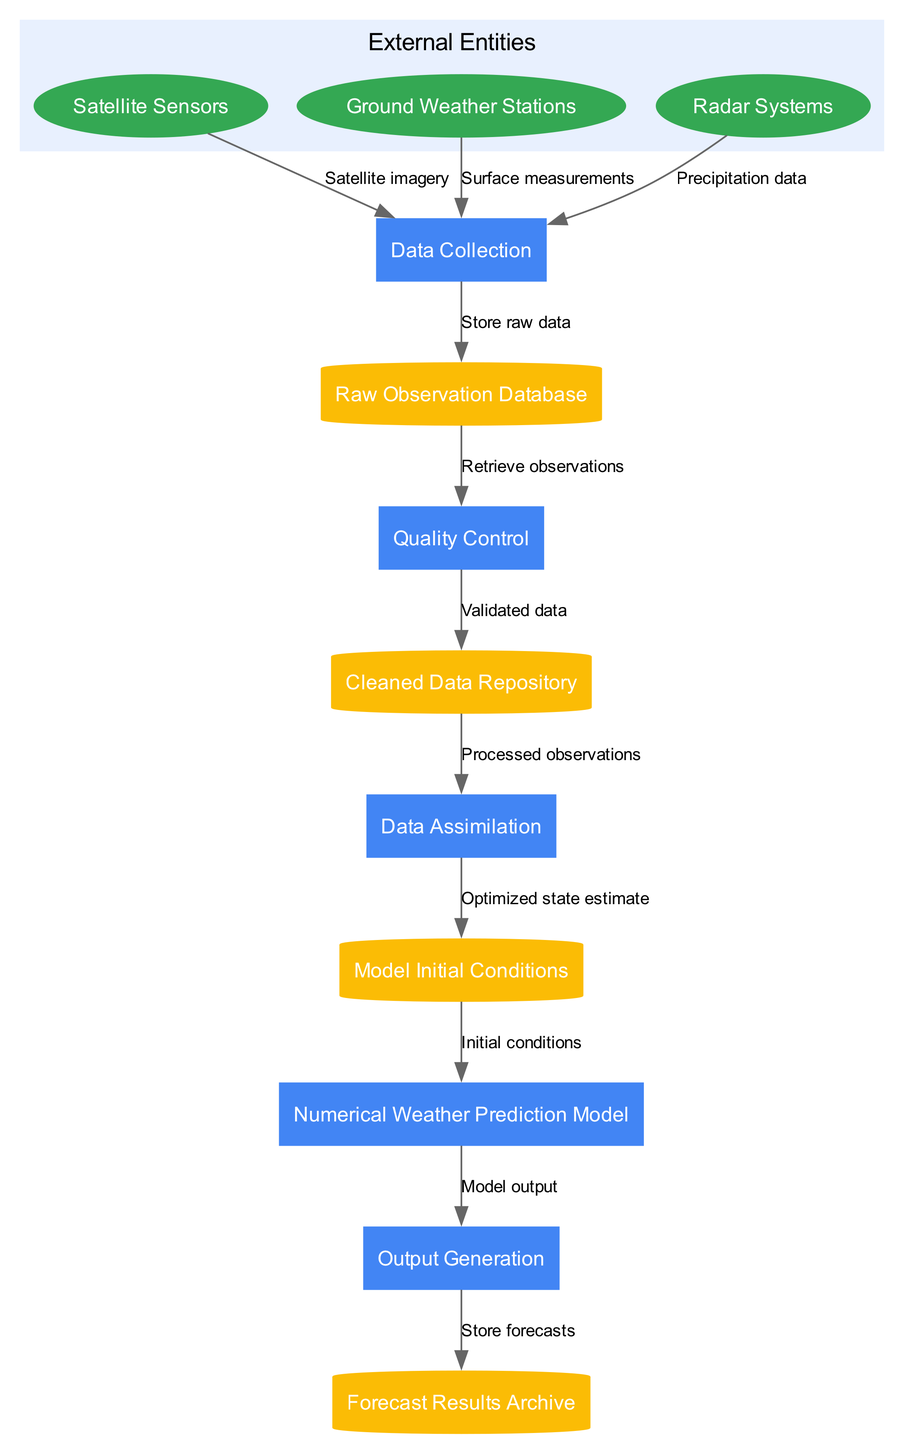What are the external entities represented in the diagram? The diagram lists three external entities: Satellite Sensors, Ground Weather Stations, and Radar Systems, which are depicted in ovals.
Answer: Satellite Sensors, Ground Weather Stations, Radar Systems How many processes are included in the data processing pipeline? By counting the rectangles representing processes in the diagram, we find five distinct processes: Data Collection, Quality Control, Data Assimilation, Numerical Weather Prediction Model, and Output Generation.
Answer: 5 What data flow goes from Data Collection to Raw Observation Database? The data flow is labeled "Store raw data," illustrating that the raw data collected from various sources is stored in the Raw Observation Database.
Answer: Store raw data Which process outputs the "Model output"? The data flow indicates that the Numerical Weather Prediction Model is responsible for generating the output labeled "Model output," which is then forwarded to the Output Generation process.
Answer: Numerical Weather Prediction Model What is the final step in the data processing pipeline? The final step in the data flow is Output Generation, which involves storing forecasts in the Forecast Results Archive, as shown by the last edge in the diagram.
Answer: Output Generation What type of data do Ground Weather Stations provide to the pipeline? Ground Weather Stations contribute "Surface measurements" as indicated by the data flow from these stations to the Data Collection process.
Answer: Surface measurements Which data store holds the "Optimized state estimate"? The Model Initial Conditions data store is where the data flowing from the Data Assimilation process is stored, labeled "Optimized state estimate."
Answer: Model Initial Conditions How does data flow from the Cleaned Data Repository to Data Assimilation? The data flow labeled "Processed observations" indicates that the cleaned and validated data from the Cleaned Data Repository is fed into the Data Assimilation process.
Answer: Processed observations What is the purpose of the Quality Control process? The Quality Control process ensures that "Validated data" is produced and sent to the Cleaned Data Repository, as signified by the corresponding data flow in the diagram.
Answer: Validated data 